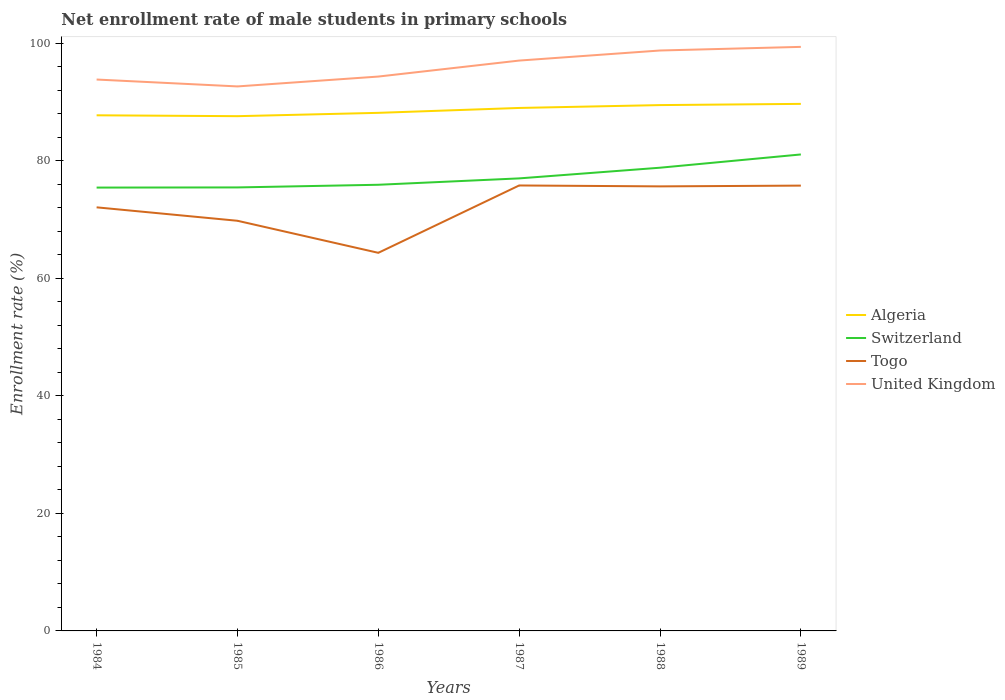Is the number of lines equal to the number of legend labels?
Provide a short and direct response. Yes. Across all years, what is the maximum net enrollment rate of male students in primary schools in Algeria?
Your answer should be very brief. 87.61. What is the total net enrollment rate of male students in primary schools in Algeria in the graph?
Ensure brevity in your answer.  -0.21. What is the difference between the highest and the second highest net enrollment rate of male students in primary schools in Algeria?
Make the answer very short. 2.09. What is the difference between the highest and the lowest net enrollment rate of male students in primary schools in Togo?
Your answer should be compact. 3. Is the net enrollment rate of male students in primary schools in Switzerland strictly greater than the net enrollment rate of male students in primary schools in Algeria over the years?
Keep it short and to the point. Yes. Does the graph contain any zero values?
Ensure brevity in your answer.  No. Does the graph contain grids?
Offer a very short reply. No. Where does the legend appear in the graph?
Ensure brevity in your answer.  Center right. How many legend labels are there?
Provide a short and direct response. 4. What is the title of the graph?
Ensure brevity in your answer.  Net enrollment rate of male students in primary schools. What is the label or title of the Y-axis?
Make the answer very short. Enrollment rate (%). What is the Enrollment rate (%) in Algeria in 1984?
Ensure brevity in your answer.  87.76. What is the Enrollment rate (%) in Switzerland in 1984?
Give a very brief answer. 75.45. What is the Enrollment rate (%) of Togo in 1984?
Keep it short and to the point. 72.09. What is the Enrollment rate (%) of United Kingdom in 1984?
Ensure brevity in your answer.  93.84. What is the Enrollment rate (%) in Algeria in 1985?
Offer a terse response. 87.61. What is the Enrollment rate (%) of Switzerland in 1985?
Your answer should be very brief. 75.48. What is the Enrollment rate (%) of Togo in 1985?
Offer a very short reply. 69.8. What is the Enrollment rate (%) of United Kingdom in 1985?
Offer a very short reply. 92.67. What is the Enrollment rate (%) of Algeria in 1986?
Provide a short and direct response. 88.17. What is the Enrollment rate (%) of Switzerland in 1986?
Your answer should be very brief. 75.93. What is the Enrollment rate (%) of Togo in 1986?
Give a very brief answer. 64.35. What is the Enrollment rate (%) of United Kingdom in 1986?
Provide a short and direct response. 94.35. What is the Enrollment rate (%) in Algeria in 1987?
Your answer should be compact. 89.01. What is the Enrollment rate (%) in Switzerland in 1987?
Your answer should be compact. 77.02. What is the Enrollment rate (%) of Togo in 1987?
Provide a short and direct response. 75.81. What is the Enrollment rate (%) of United Kingdom in 1987?
Make the answer very short. 97.07. What is the Enrollment rate (%) of Algeria in 1988?
Your answer should be very brief. 89.49. What is the Enrollment rate (%) of Switzerland in 1988?
Provide a succinct answer. 78.84. What is the Enrollment rate (%) in Togo in 1988?
Your answer should be very brief. 75.66. What is the Enrollment rate (%) in United Kingdom in 1988?
Your response must be concise. 98.78. What is the Enrollment rate (%) in Algeria in 1989?
Provide a succinct answer. 89.7. What is the Enrollment rate (%) in Switzerland in 1989?
Your answer should be very brief. 81.09. What is the Enrollment rate (%) of Togo in 1989?
Provide a short and direct response. 75.79. What is the Enrollment rate (%) of United Kingdom in 1989?
Your response must be concise. 99.4. Across all years, what is the maximum Enrollment rate (%) of Algeria?
Your answer should be compact. 89.7. Across all years, what is the maximum Enrollment rate (%) of Switzerland?
Provide a succinct answer. 81.09. Across all years, what is the maximum Enrollment rate (%) of Togo?
Keep it short and to the point. 75.81. Across all years, what is the maximum Enrollment rate (%) in United Kingdom?
Your response must be concise. 99.4. Across all years, what is the minimum Enrollment rate (%) in Algeria?
Provide a succinct answer. 87.61. Across all years, what is the minimum Enrollment rate (%) of Switzerland?
Keep it short and to the point. 75.45. Across all years, what is the minimum Enrollment rate (%) in Togo?
Provide a short and direct response. 64.35. Across all years, what is the minimum Enrollment rate (%) in United Kingdom?
Your answer should be very brief. 92.67. What is the total Enrollment rate (%) of Algeria in the graph?
Your answer should be very brief. 531.74. What is the total Enrollment rate (%) in Switzerland in the graph?
Give a very brief answer. 463.81. What is the total Enrollment rate (%) in Togo in the graph?
Make the answer very short. 433.51. What is the total Enrollment rate (%) in United Kingdom in the graph?
Ensure brevity in your answer.  576.12. What is the difference between the Enrollment rate (%) in Algeria in 1984 and that in 1985?
Offer a terse response. 0.15. What is the difference between the Enrollment rate (%) of Switzerland in 1984 and that in 1985?
Your answer should be very brief. -0.03. What is the difference between the Enrollment rate (%) of Togo in 1984 and that in 1985?
Your answer should be compact. 2.29. What is the difference between the Enrollment rate (%) in United Kingdom in 1984 and that in 1985?
Your answer should be very brief. 1.17. What is the difference between the Enrollment rate (%) of Algeria in 1984 and that in 1986?
Keep it short and to the point. -0.42. What is the difference between the Enrollment rate (%) of Switzerland in 1984 and that in 1986?
Ensure brevity in your answer.  -0.48. What is the difference between the Enrollment rate (%) in Togo in 1984 and that in 1986?
Ensure brevity in your answer.  7.74. What is the difference between the Enrollment rate (%) of United Kingdom in 1984 and that in 1986?
Offer a terse response. -0.51. What is the difference between the Enrollment rate (%) of Algeria in 1984 and that in 1987?
Make the answer very short. -1.25. What is the difference between the Enrollment rate (%) in Switzerland in 1984 and that in 1987?
Give a very brief answer. -1.56. What is the difference between the Enrollment rate (%) in Togo in 1984 and that in 1987?
Make the answer very short. -3.72. What is the difference between the Enrollment rate (%) in United Kingdom in 1984 and that in 1987?
Make the answer very short. -3.23. What is the difference between the Enrollment rate (%) of Algeria in 1984 and that in 1988?
Give a very brief answer. -1.74. What is the difference between the Enrollment rate (%) of Switzerland in 1984 and that in 1988?
Offer a very short reply. -3.38. What is the difference between the Enrollment rate (%) in Togo in 1984 and that in 1988?
Keep it short and to the point. -3.57. What is the difference between the Enrollment rate (%) in United Kingdom in 1984 and that in 1988?
Offer a very short reply. -4.94. What is the difference between the Enrollment rate (%) in Algeria in 1984 and that in 1989?
Ensure brevity in your answer.  -1.94. What is the difference between the Enrollment rate (%) in Switzerland in 1984 and that in 1989?
Your answer should be compact. -5.64. What is the difference between the Enrollment rate (%) of Togo in 1984 and that in 1989?
Your answer should be very brief. -3.7. What is the difference between the Enrollment rate (%) of United Kingdom in 1984 and that in 1989?
Provide a succinct answer. -5.56. What is the difference between the Enrollment rate (%) of Algeria in 1985 and that in 1986?
Provide a short and direct response. -0.57. What is the difference between the Enrollment rate (%) of Switzerland in 1985 and that in 1986?
Provide a short and direct response. -0.45. What is the difference between the Enrollment rate (%) of Togo in 1985 and that in 1986?
Provide a short and direct response. 5.45. What is the difference between the Enrollment rate (%) in United Kingdom in 1985 and that in 1986?
Make the answer very short. -1.68. What is the difference between the Enrollment rate (%) of Algeria in 1985 and that in 1987?
Your answer should be very brief. -1.4. What is the difference between the Enrollment rate (%) of Switzerland in 1985 and that in 1987?
Offer a very short reply. -1.54. What is the difference between the Enrollment rate (%) of Togo in 1985 and that in 1987?
Ensure brevity in your answer.  -6.01. What is the difference between the Enrollment rate (%) in United Kingdom in 1985 and that in 1987?
Your answer should be compact. -4.4. What is the difference between the Enrollment rate (%) of Algeria in 1985 and that in 1988?
Provide a succinct answer. -1.89. What is the difference between the Enrollment rate (%) of Switzerland in 1985 and that in 1988?
Ensure brevity in your answer.  -3.35. What is the difference between the Enrollment rate (%) of Togo in 1985 and that in 1988?
Provide a succinct answer. -5.85. What is the difference between the Enrollment rate (%) of United Kingdom in 1985 and that in 1988?
Give a very brief answer. -6.11. What is the difference between the Enrollment rate (%) in Algeria in 1985 and that in 1989?
Provide a succinct answer. -2.09. What is the difference between the Enrollment rate (%) of Switzerland in 1985 and that in 1989?
Your answer should be very brief. -5.61. What is the difference between the Enrollment rate (%) of Togo in 1985 and that in 1989?
Give a very brief answer. -5.99. What is the difference between the Enrollment rate (%) in United Kingdom in 1985 and that in 1989?
Your answer should be compact. -6.73. What is the difference between the Enrollment rate (%) in Algeria in 1986 and that in 1987?
Make the answer very short. -0.83. What is the difference between the Enrollment rate (%) of Switzerland in 1986 and that in 1987?
Provide a succinct answer. -1.08. What is the difference between the Enrollment rate (%) in Togo in 1986 and that in 1987?
Give a very brief answer. -11.46. What is the difference between the Enrollment rate (%) in United Kingdom in 1986 and that in 1987?
Make the answer very short. -2.72. What is the difference between the Enrollment rate (%) in Algeria in 1986 and that in 1988?
Your answer should be compact. -1.32. What is the difference between the Enrollment rate (%) in Switzerland in 1986 and that in 1988?
Your answer should be compact. -2.9. What is the difference between the Enrollment rate (%) of Togo in 1986 and that in 1988?
Give a very brief answer. -11.31. What is the difference between the Enrollment rate (%) in United Kingdom in 1986 and that in 1988?
Your answer should be very brief. -4.44. What is the difference between the Enrollment rate (%) of Algeria in 1986 and that in 1989?
Your answer should be very brief. -1.53. What is the difference between the Enrollment rate (%) of Switzerland in 1986 and that in 1989?
Provide a succinct answer. -5.16. What is the difference between the Enrollment rate (%) of Togo in 1986 and that in 1989?
Your response must be concise. -11.44. What is the difference between the Enrollment rate (%) in United Kingdom in 1986 and that in 1989?
Offer a terse response. -5.05. What is the difference between the Enrollment rate (%) in Algeria in 1987 and that in 1988?
Your response must be concise. -0.49. What is the difference between the Enrollment rate (%) of Switzerland in 1987 and that in 1988?
Offer a very short reply. -1.82. What is the difference between the Enrollment rate (%) of Togo in 1987 and that in 1988?
Provide a short and direct response. 0.16. What is the difference between the Enrollment rate (%) in United Kingdom in 1987 and that in 1988?
Your response must be concise. -1.71. What is the difference between the Enrollment rate (%) of Algeria in 1987 and that in 1989?
Ensure brevity in your answer.  -0.7. What is the difference between the Enrollment rate (%) in Switzerland in 1987 and that in 1989?
Offer a terse response. -4.07. What is the difference between the Enrollment rate (%) of Togo in 1987 and that in 1989?
Keep it short and to the point. 0.02. What is the difference between the Enrollment rate (%) of United Kingdom in 1987 and that in 1989?
Offer a very short reply. -2.33. What is the difference between the Enrollment rate (%) of Algeria in 1988 and that in 1989?
Give a very brief answer. -0.21. What is the difference between the Enrollment rate (%) in Switzerland in 1988 and that in 1989?
Your response must be concise. -2.26. What is the difference between the Enrollment rate (%) in Togo in 1988 and that in 1989?
Provide a succinct answer. -0.13. What is the difference between the Enrollment rate (%) of United Kingdom in 1988 and that in 1989?
Ensure brevity in your answer.  -0.62. What is the difference between the Enrollment rate (%) in Algeria in 1984 and the Enrollment rate (%) in Switzerland in 1985?
Provide a short and direct response. 12.28. What is the difference between the Enrollment rate (%) in Algeria in 1984 and the Enrollment rate (%) in Togo in 1985?
Provide a succinct answer. 17.95. What is the difference between the Enrollment rate (%) of Algeria in 1984 and the Enrollment rate (%) of United Kingdom in 1985?
Provide a short and direct response. -4.91. What is the difference between the Enrollment rate (%) of Switzerland in 1984 and the Enrollment rate (%) of Togo in 1985?
Keep it short and to the point. 5.65. What is the difference between the Enrollment rate (%) in Switzerland in 1984 and the Enrollment rate (%) in United Kingdom in 1985?
Your answer should be very brief. -17.22. What is the difference between the Enrollment rate (%) in Togo in 1984 and the Enrollment rate (%) in United Kingdom in 1985?
Keep it short and to the point. -20.58. What is the difference between the Enrollment rate (%) of Algeria in 1984 and the Enrollment rate (%) of Switzerland in 1986?
Offer a terse response. 11.82. What is the difference between the Enrollment rate (%) in Algeria in 1984 and the Enrollment rate (%) in Togo in 1986?
Offer a terse response. 23.41. What is the difference between the Enrollment rate (%) of Algeria in 1984 and the Enrollment rate (%) of United Kingdom in 1986?
Provide a short and direct response. -6.59. What is the difference between the Enrollment rate (%) of Switzerland in 1984 and the Enrollment rate (%) of Togo in 1986?
Ensure brevity in your answer.  11.1. What is the difference between the Enrollment rate (%) of Switzerland in 1984 and the Enrollment rate (%) of United Kingdom in 1986?
Provide a short and direct response. -18.89. What is the difference between the Enrollment rate (%) of Togo in 1984 and the Enrollment rate (%) of United Kingdom in 1986?
Give a very brief answer. -22.26. What is the difference between the Enrollment rate (%) of Algeria in 1984 and the Enrollment rate (%) of Switzerland in 1987?
Your answer should be compact. 10.74. What is the difference between the Enrollment rate (%) in Algeria in 1984 and the Enrollment rate (%) in Togo in 1987?
Keep it short and to the point. 11.94. What is the difference between the Enrollment rate (%) in Algeria in 1984 and the Enrollment rate (%) in United Kingdom in 1987?
Offer a very short reply. -9.31. What is the difference between the Enrollment rate (%) in Switzerland in 1984 and the Enrollment rate (%) in Togo in 1987?
Your response must be concise. -0.36. What is the difference between the Enrollment rate (%) in Switzerland in 1984 and the Enrollment rate (%) in United Kingdom in 1987?
Your response must be concise. -21.62. What is the difference between the Enrollment rate (%) in Togo in 1984 and the Enrollment rate (%) in United Kingdom in 1987?
Your answer should be compact. -24.98. What is the difference between the Enrollment rate (%) in Algeria in 1984 and the Enrollment rate (%) in Switzerland in 1988?
Keep it short and to the point. 8.92. What is the difference between the Enrollment rate (%) in Algeria in 1984 and the Enrollment rate (%) in Togo in 1988?
Provide a succinct answer. 12.1. What is the difference between the Enrollment rate (%) of Algeria in 1984 and the Enrollment rate (%) of United Kingdom in 1988?
Make the answer very short. -11.03. What is the difference between the Enrollment rate (%) in Switzerland in 1984 and the Enrollment rate (%) in Togo in 1988?
Give a very brief answer. -0.2. What is the difference between the Enrollment rate (%) of Switzerland in 1984 and the Enrollment rate (%) of United Kingdom in 1988?
Keep it short and to the point. -23.33. What is the difference between the Enrollment rate (%) in Togo in 1984 and the Enrollment rate (%) in United Kingdom in 1988?
Provide a short and direct response. -26.69. What is the difference between the Enrollment rate (%) in Algeria in 1984 and the Enrollment rate (%) in Switzerland in 1989?
Make the answer very short. 6.67. What is the difference between the Enrollment rate (%) in Algeria in 1984 and the Enrollment rate (%) in Togo in 1989?
Offer a terse response. 11.97. What is the difference between the Enrollment rate (%) in Algeria in 1984 and the Enrollment rate (%) in United Kingdom in 1989?
Provide a succinct answer. -11.64. What is the difference between the Enrollment rate (%) of Switzerland in 1984 and the Enrollment rate (%) of Togo in 1989?
Make the answer very short. -0.34. What is the difference between the Enrollment rate (%) in Switzerland in 1984 and the Enrollment rate (%) in United Kingdom in 1989?
Offer a terse response. -23.95. What is the difference between the Enrollment rate (%) of Togo in 1984 and the Enrollment rate (%) of United Kingdom in 1989?
Your answer should be compact. -27.31. What is the difference between the Enrollment rate (%) of Algeria in 1985 and the Enrollment rate (%) of Switzerland in 1986?
Offer a terse response. 11.67. What is the difference between the Enrollment rate (%) in Algeria in 1985 and the Enrollment rate (%) in Togo in 1986?
Your response must be concise. 23.26. What is the difference between the Enrollment rate (%) in Algeria in 1985 and the Enrollment rate (%) in United Kingdom in 1986?
Give a very brief answer. -6.74. What is the difference between the Enrollment rate (%) of Switzerland in 1985 and the Enrollment rate (%) of Togo in 1986?
Give a very brief answer. 11.13. What is the difference between the Enrollment rate (%) in Switzerland in 1985 and the Enrollment rate (%) in United Kingdom in 1986?
Provide a short and direct response. -18.87. What is the difference between the Enrollment rate (%) of Togo in 1985 and the Enrollment rate (%) of United Kingdom in 1986?
Keep it short and to the point. -24.54. What is the difference between the Enrollment rate (%) in Algeria in 1985 and the Enrollment rate (%) in Switzerland in 1987?
Give a very brief answer. 10.59. What is the difference between the Enrollment rate (%) of Algeria in 1985 and the Enrollment rate (%) of Togo in 1987?
Offer a very short reply. 11.79. What is the difference between the Enrollment rate (%) in Algeria in 1985 and the Enrollment rate (%) in United Kingdom in 1987?
Your response must be concise. -9.46. What is the difference between the Enrollment rate (%) in Switzerland in 1985 and the Enrollment rate (%) in Togo in 1987?
Your response must be concise. -0.33. What is the difference between the Enrollment rate (%) of Switzerland in 1985 and the Enrollment rate (%) of United Kingdom in 1987?
Your response must be concise. -21.59. What is the difference between the Enrollment rate (%) in Togo in 1985 and the Enrollment rate (%) in United Kingdom in 1987?
Give a very brief answer. -27.27. What is the difference between the Enrollment rate (%) in Algeria in 1985 and the Enrollment rate (%) in Switzerland in 1988?
Provide a short and direct response. 8.77. What is the difference between the Enrollment rate (%) of Algeria in 1985 and the Enrollment rate (%) of Togo in 1988?
Provide a short and direct response. 11.95. What is the difference between the Enrollment rate (%) of Algeria in 1985 and the Enrollment rate (%) of United Kingdom in 1988?
Make the answer very short. -11.18. What is the difference between the Enrollment rate (%) in Switzerland in 1985 and the Enrollment rate (%) in Togo in 1988?
Offer a very short reply. -0.18. What is the difference between the Enrollment rate (%) of Switzerland in 1985 and the Enrollment rate (%) of United Kingdom in 1988?
Your answer should be very brief. -23.3. What is the difference between the Enrollment rate (%) of Togo in 1985 and the Enrollment rate (%) of United Kingdom in 1988?
Offer a terse response. -28.98. What is the difference between the Enrollment rate (%) of Algeria in 1985 and the Enrollment rate (%) of Switzerland in 1989?
Give a very brief answer. 6.52. What is the difference between the Enrollment rate (%) in Algeria in 1985 and the Enrollment rate (%) in Togo in 1989?
Provide a short and direct response. 11.82. What is the difference between the Enrollment rate (%) in Algeria in 1985 and the Enrollment rate (%) in United Kingdom in 1989?
Offer a very short reply. -11.79. What is the difference between the Enrollment rate (%) in Switzerland in 1985 and the Enrollment rate (%) in Togo in 1989?
Ensure brevity in your answer.  -0.31. What is the difference between the Enrollment rate (%) of Switzerland in 1985 and the Enrollment rate (%) of United Kingdom in 1989?
Ensure brevity in your answer.  -23.92. What is the difference between the Enrollment rate (%) of Togo in 1985 and the Enrollment rate (%) of United Kingdom in 1989?
Make the answer very short. -29.6. What is the difference between the Enrollment rate (%) of Algeria in 1986 and the Enrollment rate (%) of Switzerland in 1987?
Offer a very short reply. 11.16. What is the difference between the Enrollment rate (%) in Algeria in 1986 and the Enrollment rate (%) in Togo in 1987?
Offer a very short reply. 12.36. What is the difference between the Enrollment rate (%) in Algeria in 1986 and the Enrollment rate (%) in United Kingdom in 1987?
Your answer should be very brief. -8.9. What is the difference between the Enrollment rate (%) of Switzerland in 1986 and the Enrollment rate (%) of Togo in 1987?
Provide a short and direct response. 0.12. What is the difference between the Enrollment rate (%) of Switzerland in 1986 and the Enrollment rate (%) of United Kingdom in 1987?
Ensure brevity in your answer.  -21.14. What is the difference between the Enrollment rate (%) in Togo in 1986 and the Enrollment rate (%) in United Kingdom in 1987?
Your answer should be compact. -32.72. What is the difference between the Enrollment rate (%) in Algeria in 1986 and the Enrollment rate (%) in Switzerland in 1988?
Your answer should be very brief. 9.34. What is the difference between the Enrollment rate (%) of Algeria in 1986 and the Enrollment rate (%) of Togo in 1988?
Provide a succinct answer. 12.52. What is the difference between the Enrollment rate (%) of Algeria in 1986 and the Enrollment rate (%) of United Kingdom in 1988?
Ensure brevity in your answer.  -10.61. What is the difference between the Enrollment rate (%) in Switzerland in 1986 and the Enrollment rate (%) in Togo in 1988?
Provide a short and direct response. 0.28. What is the difference between the Enrollment rate (%) of Switzerland in 1986 and the Enrollment rate (%) of United Kingdom in 1988?
Your answer should be very brief. -22.85. What is the difference between the Enrollment rate (%) of Togo in 1986 and the Enrollment rate (%) of United Kingdom in 1988?
Provide a short and direct response. -34.43. What is the difference between the Enrollment rate (%) of Algeria in 1986 and the Enrollment rate (%) of Switzerland in 1989?
Offer a terse response. 7.08. What is the difference between the Enrollment rate (%) in Algeria in 1986 and the Enrollment rate (%) in Togo in 1989?
Your response must be concise. 12.38. What is the difference between the Enrollment rate (%) of Algeria in 1986 and the Enrollment rate (%) of United Kingdom in 1989?
Provide a succinct answer. -11.23. What is the difference between the Enrollment rate (%) in Switzerland in 1986 and the Enrollment rate (%) in Togo in 1989?
Ensure brevity in your answer.  0.14. What is the difference between the Enrollment rate (%) of Switzerland in 1986 and the Enrollment rate (%) of United Kingdom in 1989?
Give a very brief answer. -23.47. What is the difference between the Enrollment rate (%) of Togo in 1986 and the Enrollment rate (%) of United Kingdom in 1989?
Keep it short and to the point. -35.05. What is the difference between the Enrollment rate (%) in Algeria in 1987 and the Enrollment rate (%) in Switzerland in 1988?
Keep it short and to the point. 10.17. What is the difference between the Enrollment rate (%) of Algeria in 1987 and the Enrollment rate (%) of Togo in 1988?
Provide a succinct answer. 13.35. What is the difference between the Enrollment rate (%) of Algeria in 1987 and the Enrollment rate (%) of United Kingdom in 1988?
Provide a succinct answer. -9.78. What is the difference between the Enrollment rate (%) in Switzerland in 1987 and the Enrollment rate (%) in Togo in 1988?
Provide a succinct answer. 1.36. What is the difference between the Enrollment rate (%) in Switzerland in 1987 and the Enrollment rate (%) in United Kingdom in 1988?
Provide a short and direct response. -21.77. What is the difference between the Enrollment rate (%) in Togo in 1987 and the Enrollment rate (%) in United Kingdom in 1988?
Make the answer very short. -22.97. What is the difference between the Enrollment rate (%) of Algeria in 1987 and the Enrollment rate (%) of Switzerland in 1989?
Provide a succinct answer. 7.91. What is the difference between the Enrollment rate (%) in Algeria in 1987 and the Enrollment rate (%) in Togo in 1989?
Give a very brief answer. 13.22. What is the difference between the Enrollment rate (%) in Algeria in 1987 and the Enrollment rate (%) in United Kingdom in 1989?
Provide a succinct answer. -10.4. What is the difference between the Enrollment rate (%) of Switzerland in 1987 and the Enrollment rate (%) of Togo in 1989?
Keep it short and to the point. 1.23. What is the difference between the Enrollment rate (%) of Switzerland in 1987 and the Enrollment rate (%) of United Kingdom in 1989?
Make the answer very short. -22.38. What is the difference between the Enrollment rate (%) in Togo in 1987 and the Enrollment rate (%) in United Kingdom in 1989?
Offer a terse response. -23.59. What is the difference between the Enrollment rate (%) in Algeria in 1988 and the Enrollment rate (%) in Switzerland in 1989?
Give a very brief answer. 8.4. What is the difference between the Enrollment rate (%) of Algeria in 1988 and the Enrollment rate (%) of Togo in 1989?
Your answer should be very brief. 13.7. What is the difference between the Enrollment rate (%) in Algeria in 1988 and the Enrollment rate (%) in United Kingdom in 1989?
Offer a terse response. -9.91. What is the difference between the Enrollment rate (%) in Switzerland in 1988 and the Enrollment rate (%) in Togo in 1989?
Your answer should be very brief. 3.05. What is the difference between the Enrollment rate (%) of Switzerland in 1988 and the Enrollment rate (%) of United Kingdom in 1989?
Offer a terse response. -20.57. What is the difference between the Enrollment rate (%) in Togo in 1988 and the Enrollment rate (%) in United Kingdom in 1989?
Offer a terse response. -23.74. What is the average Enrollment rate (%) in Algeria per year?
Your answer should be very brief. 88.62. What is the average Enrollment rate (%) of Switzerland per year?
Provide a short and direct response. 77.3. What is the average Enrollment rate (%) in Togo per year?
Offer a terse response. 72.25. What is the average Enrollment rate (%) in United Kingdom per year?
Provide a succinct answer. 96.02. In the year 1984, what is the difference between the Enrollment rate (%) of Algeria and Enrollment rate (%) of Switzerland?
Make the answer very short. 12.3. In the year 1984, what is the difference between the Enrollment rate (%) in Algeria and Enrollment rate (%) in Togo?
Provide a succinct answer. 15.66. In the year 1984, what is the difference between the Enrollment rate (%) in Algeria and Enrollment rate (%) in United Kingdom?
Make the answer very short. -6.09. In the year 1984, what is the difference between the Enrollment rate (%) of Switzerland and Enrollment rate (%) of Togo?
Your response must be concise. 3.36. In the year 1984, what is the difference between the Enrollment rate (%) in Switzerland and Enrollment rate (%) in United Kingdom?
Offer a terse response. -18.39. In the year 1984, what is the difference between the Enrollment rate (%) of Togo and Enrollment rate (%) of United Kingdom?
Offer a very short reply. -21.75. In the year 1985, what is the difference between the Enrollment rate (%) in Algeria and Enrollment rate (%) in Switzerland?
Keep it short and to the point. 12.13. In the year 1985, what is the difference between the Enrollment rate (%) in Algeria and Enrollment rate (%) in Togo?
Your answer should be very brief. 17.8. In the year 1985, what is the difference between the Enrollment rate (%) of Algeria and Enrollment rate (%) of United Kingdom?
Your response must be concise. -5.06. In the year 1985, what is the difference between the Enrollment rate (%) of Switzerland and Enrollment rate (%) of Togo?
Your answer should be compact. 5.68. In the year 1985, what is the difference between the Enrollment rate (%) of Switzerland and Enrollment rate (%) of United Kingdom?
Ensure brevity in your answer.  -17.19. In the year 1985, what is the difference between the Enrollment rate (%) of Togo and Enrollment rate (%) of United Kingdom?
Provide a short and direct response. -22.87. In the year 1986, what is the difference between the Enrollment rate (%) in Algeria and Enrollment rate (%) in Switzerland?
Give a very brief answer. 12.24. In the year 1986, what is the difference between the Enrollment rate (%) of Algeria and Enrollment rate (%) of Togo?
Give a very brief answer. 23.82. In the year 1986, what is the difference between the Enrollment rate (%) in Algeria and Enrollment rate (%) in United Kingdom?
Offer a terse response. -6.17. In the year 1986, what is the difference between the Enrollment rate (%) in Switzerland and Enrollment rate (%) in Togo?
Keep it short and to the point. 11.58. In the year 1986, what is the difference between the Enrollment rate (%) of Switzerland and Enrollment rate (%) of United Kingdom?
Provide a succinct answer. -18.41. In the year 1986, what is the difference between the Enrollment rate (%) of Togo and Enrollment rate (%) of United Kingdom?
Offer a terse response. -30. In the year 1987, what is the difference between the Enrollment rate (%) in Algeria and Enrollment rate (%) in Switzerland?
Ensure brevity in your answer.  11.99. In the year 1987, what is the difference between the Enrollment rate (%) in Algeria and Enrollment rate (%) in Togo?
Provide a succinct answer. 13.19. In the year 1987, what is the difference between the Enrollment rate (%) in Algeria and Enrollment rate (%) in United Kingdom?
Your answer should be compact. -8.06. In the year 1987, what is the difference between the Enrollment rate (%) of Switzerland and Enrollment rate (%) of Togo?
Ensure brevity in your answer.  1.2. In the year 1987, what is the difference between the Enrollment rate (%) in Switzerland and Enrollment rate (%) in United Kingdom?
Keep it short and to the point. -20.05. In the year 1987, what is the difference between the Enrollment rate (%) in Togo and Enrollment rate (%) in United Kingdom?
Keep it short and to the point. -21.26. In the year 1988, what is the difference between the Enrollment rate (%) in Algeria and Enrollment rate (%) in Switzerland?
Your response must be concise. 10.66. In the year 1988, what is the difference between the Enrollment rate (%) in Algeria and Enrollment rate (%) in Togo?
Your answer should be compact. 13.83. In the year 1988, what is the difference between the Enrollment rate (%) of Algeria and Enrollment rate (%) of United Kingdom?
Give a very brief answer. -9.29. In the year 1988, what is the difference between the Enrollment rate (%) in Switzerland and Enrollment rate (%) in Togo?
Give a very brief answer. 3.18. In the year 1988, what is the difference between the Enrollment rate (%) in Switzerland and Enrollment rate (%) in United Kingdom?
Provide a succinct answer. -19.95. In the year 1988, what is the difference between the Enrollment rate (%) in Togo and Enrollment rate (%) in United Kingdom?
Provide a short and direct response. -23.13. In the year 1989, what is the difference between the Enrollment rate (%) of Algeria and Enrollment rate (%) of Switzerland?
Your answer should be very brief. 8.61. In the year 1989, what is the difference between the Enrollment rate (%) of Algeria and Enrollment rate (%) of Togo?
Give a very brief answer. 13.91. In the year 1989, what is the difference between the Enrollment rate (%) in Algeria and Enrollment rate (%) in United Kingdom?
Your answer should be compact. -9.7. In the year 1989, what is the difference between the Enrollment rate (%) of Switzerland and Enrollment rate (%) of Togo?
Your response must be concise. 5.3. In the year 1989, what is the difference between the Enrollment rate (%) in Switzerland and Enrollment rate (%) in United Kingdom?
Give a very brief answer. -18.31. In the year 1989, what is the difference between the Enrollment rate (%) of Togo and Enrollment rate (%) of United Kingdom?
Your answer should be very brief. -23.61. What is the ratio of the Enrollment rate (%) of Algeria in 1984 to that in 1985?
Your answer should be compact. 1. What is the ratio of the Enrollment rate (%) of Switzerland in 1984 to that in 1985?
Your answer should be compact. 1. What is the ratio of the Enrollment rate (%) in Togo in 1984 to that in 1985?
Keep it short and to the point. 1.03. What is the ratio of the Enrollment rate (%) in United Kingdom in 1984 to that in 1985?
Provide a short and direct response. 1.01. What is the ratio of the Enrollment rate (%) of Algeria in 1984 to that in 1986?
Keep it short and to the point. 1. What is the ratio of the Enrollment rate (%) in Togo in 1984 to that in 1986?
Your answer should be very brief. 1.12. What is the ratio of the Enrollment rate (%) in Algeria in 1984 to that in 1987?
Provide a succinct answer. 0.99. What is the ratio of the Enrollment rate (%) of Switzerland in 1984 to that in 1987?
Offer a very short reply. 0.98. What is the ratio of the Enrollment rate (%) of Togo in 1984 to that in 1987?
Give a very brief answer. 0.95. What is the ratio of the Enrollment rate (%) of United Kingdom in 1984 to that in 1987?
Offer a very short reply. 0.97. What is the ratio of the Enrollment rate (%) of Algeria in 1984 to that in 1988?
Keep it short and to the point. 0.98. What is the ratio of the Enrollment rate (%) of Switzerland in 1984 to that in 1988?
Provide a succinct answer. 0.96. What is the ratio of the Enrollment rate (%) of Togo in 1984 to that in 1988?
Provide a succinct answer. 0.95. What is the ratio of the Enrollment rate (%) in United Kingdom in 1984 to that in 1988?
Your answer should be compact. 0.95. What is the ratio of the Enrollment rate (%) in Algeria in 1984 to that in 1989?
Provide a succinct answer. 0.98. What is the ratio of the Enrollment rate (%) in Switzerland in 1984 to that in 1989?
Offer a very short reply. 0.93. What is the ratio of the Enrollment rate (%) of Togo in 1984 to that in 1989?
Your response must be concise. 0.95. What is the ratio of the Enrollment rate (%) of United Kingdom in 1984 to that in 1989?
Your response must be concise. 0.94. What is the ratio of the Enrollment rate (%) of Togo in 1985 to that in 1986?
Offer a very short reply. 1.08. What is the ratio of the Enrollment rate (%) of United Kingdom in 1985 to that in 1986?
Make the answer very short. 0.98. What is the ratio of the Enrollment rate (%) in Algeria in 1985 to that in 1987?
Offer a terse response. 0.98. What is the ratio of the Enrollment rate (%) of Switzerland in 1985 to that in 1987?
Your answer should be compact. 0.98. What is the ratio of the Enrollment rate (%) of Togo in 1985 to that in 1987?
Provide a short and direct response. 0.92. What is the ratio of the Enrollment rate (%) in United Kingdom in 1985 to that in 1987?
Your response must be concise. 0.95. What is the ratio of the Enrollment rate (%) of Algeria in 1985 to that in 1988?
Offer a very short reply. 0.98. What is the ratio of the Enrollment rate (%) in Switzerland in 1985 to that in 1988?
Your response must be concise. 0.96. What is the ratio of the Enrollment rate (%) in Togo in 1985 to that in 1988?
Make the answer very short. 0.92. What is the ratio of the Enrollment rate (%) of United Kingdom in 1985 to that in 1988?
Provide a short and direct response. 0.94. What is the ratio of the Enrollment rate (%) in Algeria in 1985 to that in 1989?
Give a very brief answer. 0.98. What is the ratio of the Enrollment rate (%) in Switzerland in 1985 to that in 1989?
Provide a succinct answer. 0.93. What is the ratio of the Enrollment rate (%) of Togo in 1985 to that in 1989?
Offer a terse response. 0.92. What is the ratio of the Enrollment rate (%) in United Kingdom in 1985 to that in 1989?
Provide a short and direct response. 0.93. What is the ratio of the Enrollment rate (%) in Algeria in 1986 to that in 1987?
Offer a very short reply. 0.99. What is the ratio of the Enrollment rate (%) of Switzerland in 1986 to that in 1987?
Ensure brevity in your answer.  0.99. What is the ratio of the Enrollment rate (%) in Togo in 1986 to that in 1987?
Give a very brief answer. 0.85. What is the ratio of the Enrollment rate (%) of Algeria in 1986 to that in 1988?
Offer a very short reply. 0.99. What is the ratio of the Enrollment rate (%) in Switzerland in 1986 to that in 1988?
Provide a succinct answer. 0.96. What is the ratio of the Enrollment rate (%) in Togo in 1986 to that in 1988?
Your answer should be very brief. 0.85. What is the ratio of the Enrollment rate (%) in United Kingdom in 1986 to that in 1988?
Your answer should be very brief. 0.96. What is the ratio of the Enrollment rate (%) of Switzerland in 1986 to that in 1989?
Offer a very short reply. 0.94. What is the ratio of the Enrollment rate (%) of Togo in 1986 to that in 1989?
Your response must be concise. 0.85. What is the ratio of the Enrollment rate (%) of United Kingdom in 1986 to that in 1989?
Make the answer very short. 0.95. What is the ratio of the Enrollment rate (%) in Switzerland in 1987 to that in 1988?
Make the answer very short. 0.98. What is the ratio of the Enrollment rate (%) in Togo in 1987 to that in 1988?
Keep it short and to the point. 1. What is the ratio of the Enrollment rate (%) of United Kingdom in 1987 to that in 1988?
Keep it short and to the point. 0.98. What is the ratio of the Enrollment rate (%) of Switzerland in 1987 to that in 1989?
Ensure brevity in your answer.  0.95. What is the ratio of the Enrollment rate (%) of Togo in 1987 to that in 1989?
Provide a short and direct response. 1. What is the ratio of the Enrollment rate (%) in United Kingdom in 1987 to that in 1989?
Provide a succinct answer. 0.98. What is the ratio of the Enrollment rate (%) of Algeria in 1988 to that in 1989?
Offer a terse response. 1. What is the ratio of the Enrollment rate (%) in Switzerland in 1988 to that in 1989?
Ensure brevity in your answer.  0.97. What is the difference between the highest and the second highest Enrollment rate (%) of Algeria?
Offer a terse response. 0.21. What is the difference between the highest and the second highest Enrollment rate (%) of Switzerland?
Keep it short and to the point. 2.26. What is the difference between the highest and the second highest Enrollment rate (%) of Togo?
Keep it short and to the point. 0.02. What is the difference between the highest and the second highest Enrollment rate (%) in United Kingdom?
Make the answer very short. 0.62. What is the difference between the highest and the lowest Enrollment rate (%) of Algeria?
Ensure brevity in your answer.  2.09. What is the difference between the highest and the lowest Enrollment rate (%) of Switzerland?
Your answer should be very brief. 5.64. What is the difference between the highest and the lowest Enrollment rate (%) in Togo?
Your answer should be compact. 11.46. What is the difference between the highest and the lowest Enrollment rate (%) in United Kingdom?
Keep it short and to the point. 6.73. 